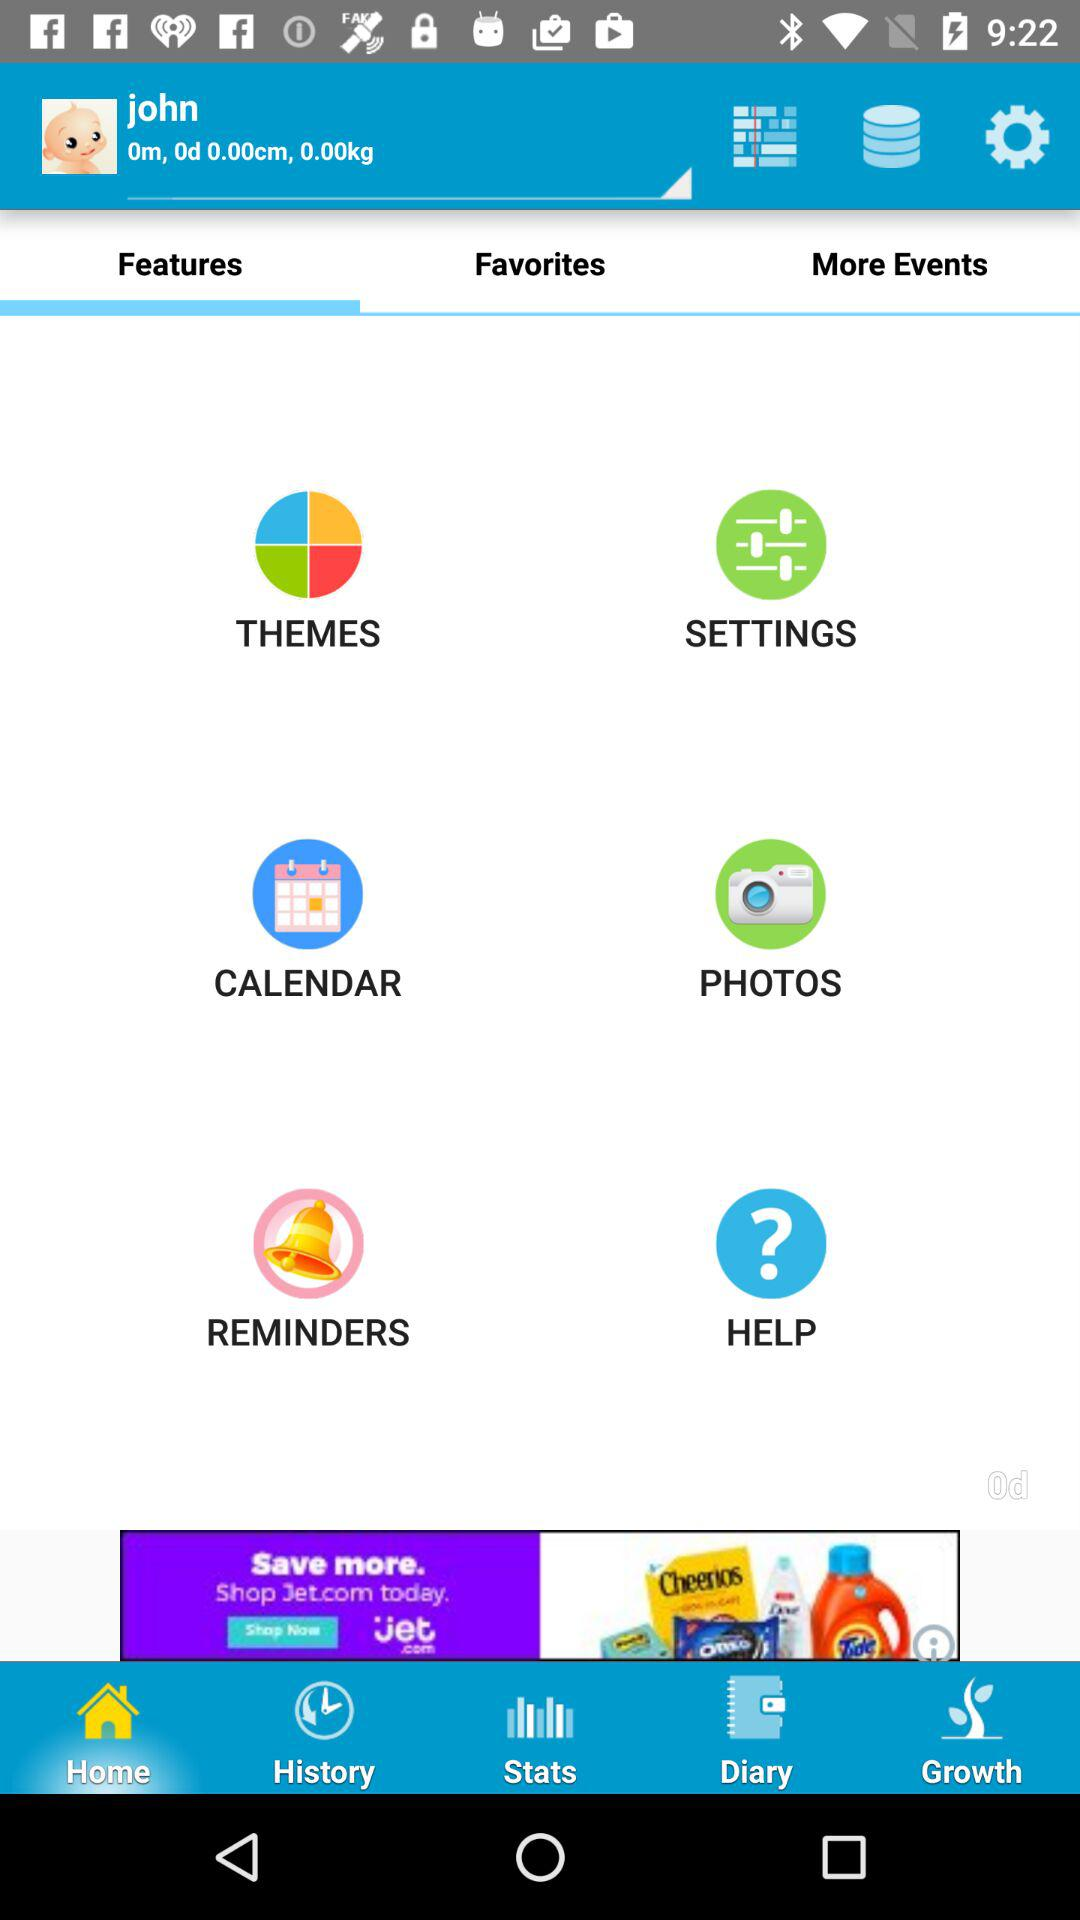Which tab are we on? You are on the "Features" tab. 